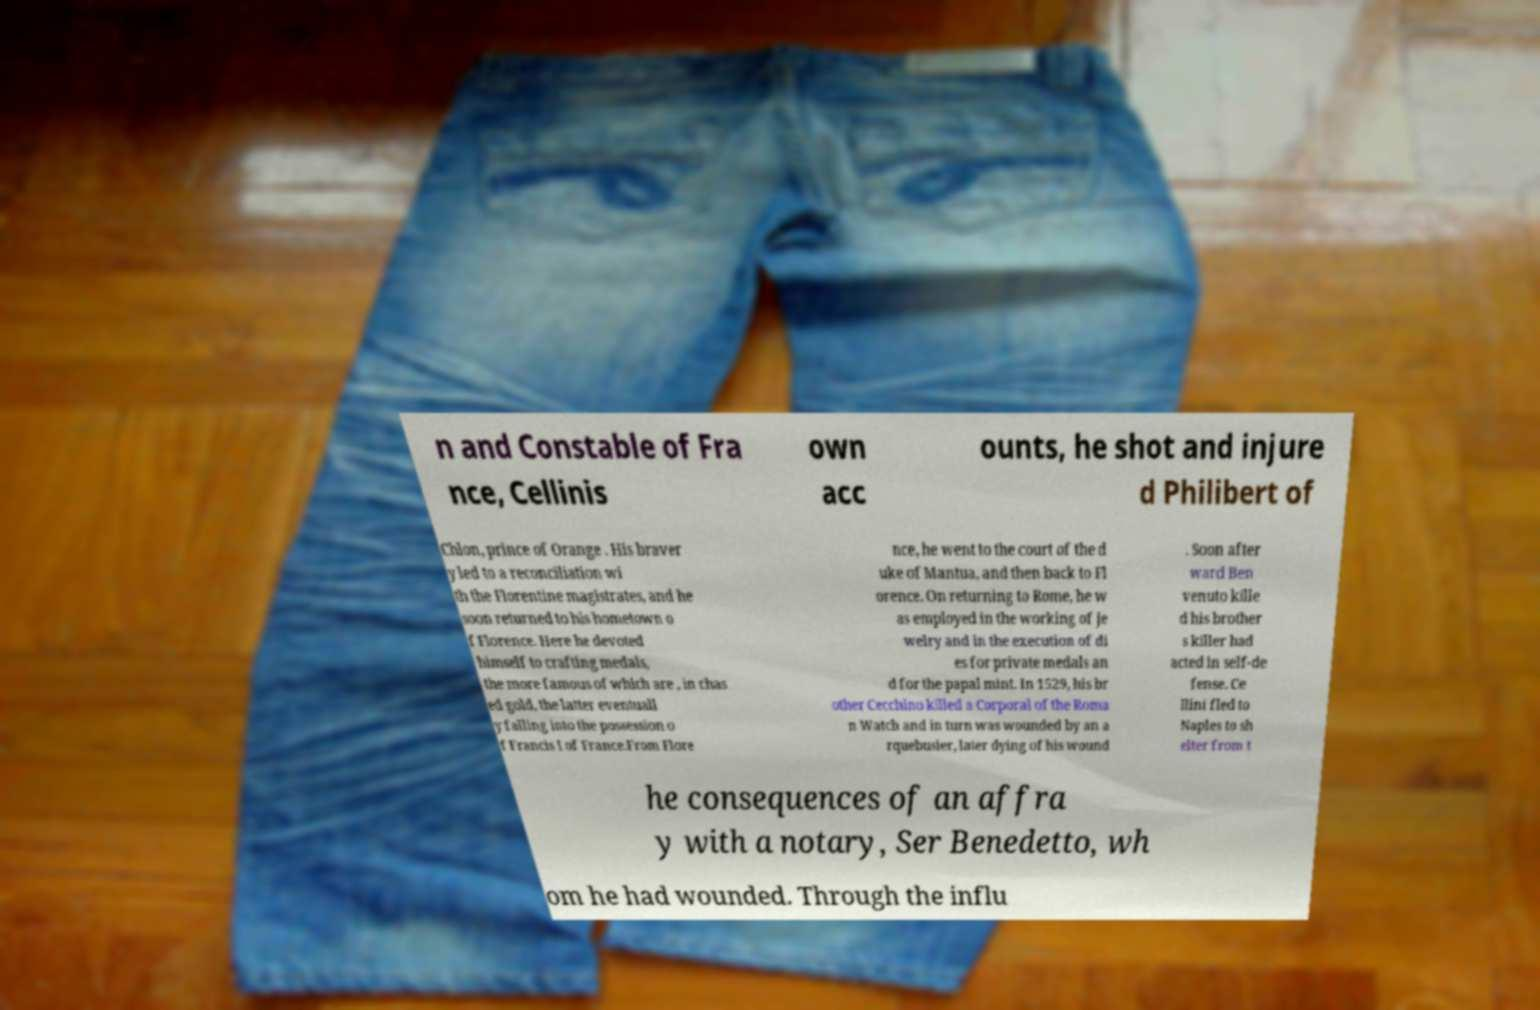I need the written content from this picture converted into text. Can you do that? n and Constable of Fra nce, Cellinis own acc ounts, he shot and injure d Philibert of Chlon, prince of Orange . His braver y led to a reconciliation wi th the Florentine magistrates, and he soon returned to his hometown o f Florence. Here he devoted himself to crafting medals, the more famous of which are , in chas ed gold, the latter eventuall y falling into the possession o f Francis I of France.From Flore nce, he went to the court of the d uke of Mantua, and then back to Fl orence. On returning to Rome, he w as employed in the working of je welry and in the execution of di es for private medals an d for the papal mint. In 1529, his br other Cecchino killed a Corporal of the Roma n Watch and in turn was wounded by an a rquebusier, later dying of his wound . Soon after ward Ben venuto kille d his brother s killer had acted in self-de fense. Ce llini fled to Naples to sh elter from t he consequences of an affra y with a notary, Ser Benedetto, wh om he had wounded. Through the influ 